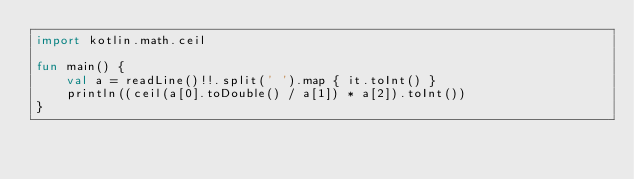<code> <loc_0><loc_0><loc_500><loc_500><_Kotlin_>import kotlin.math.ceil

fun main() {
    val a = readLine()!!.split(' ').map { it.toInt() }
    println((ceil(a[0].toDouble() / a[1]) * a[2]).toInt())
}</code> 